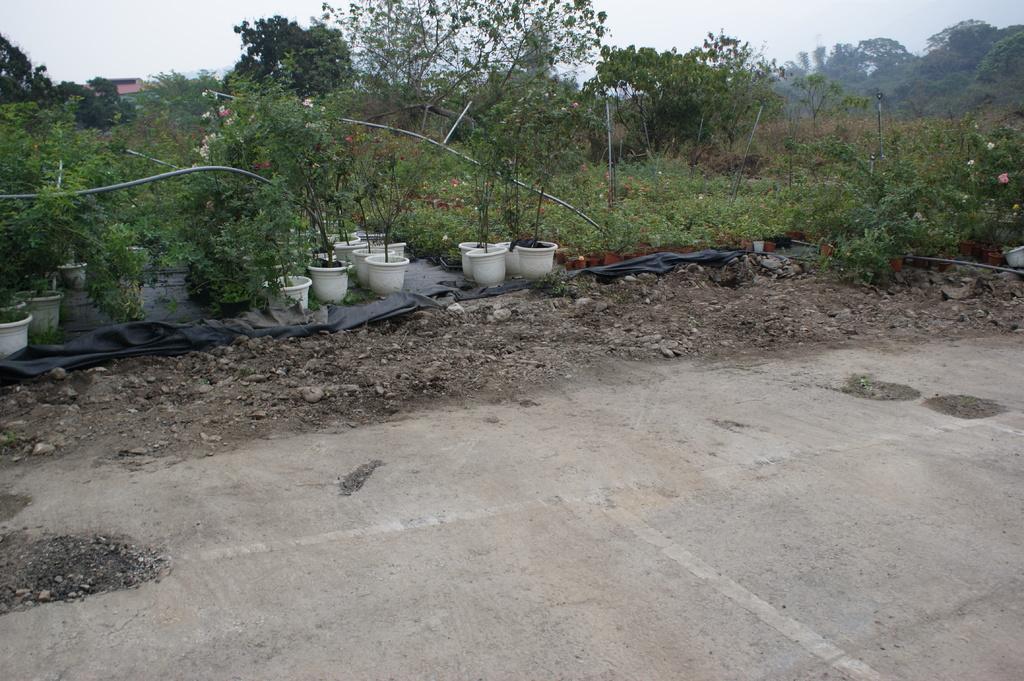Could you give a brief overview of what you see in this image? In this picture I can see the posts which are kept on the black cover. Beside that i can see some flowers on the plants. In the background i can see many trees, plants, building and mountains. In the top left corner there is a sky. At the bottom there is a road. 